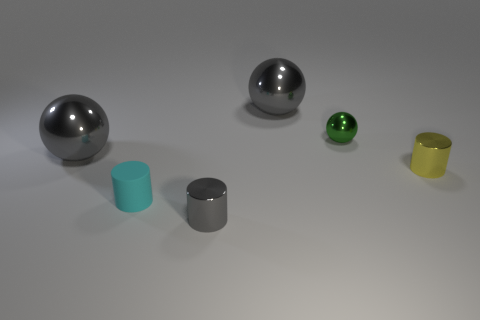Add 2 green things. How many objects exist? 8 Subtract 0 red blocks. How many objects are left? 6 Subtract all gray shiny cylinders. Subtract all big gray metal spheres. How many objects are left? 3 Add 3 cylinders. How many cylinders are left? 6 Add 2 green metal spheres. How many green metal spheres exist? 3 